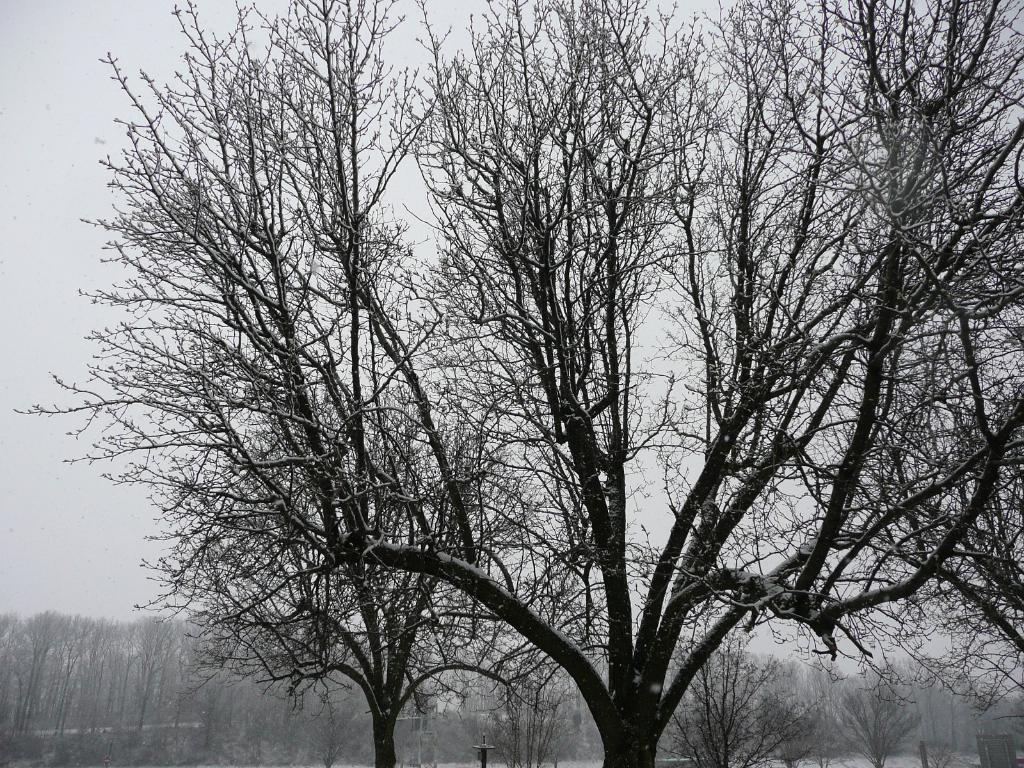What is located in the center of the image? There are trees in the center of the image. What type of natural environment is visible in the background of the image? There is snow visible in the background of the image. What else is visible in the background of the image? The sky is visible in the background of the image. Can you tell me how many police officers are sitting on the seat in the image? There are no police officers or seats present in the image. What type of object is being smashed by the trees in the image? There is no object being smashed by the trees in the image; the trees are standing upright. 